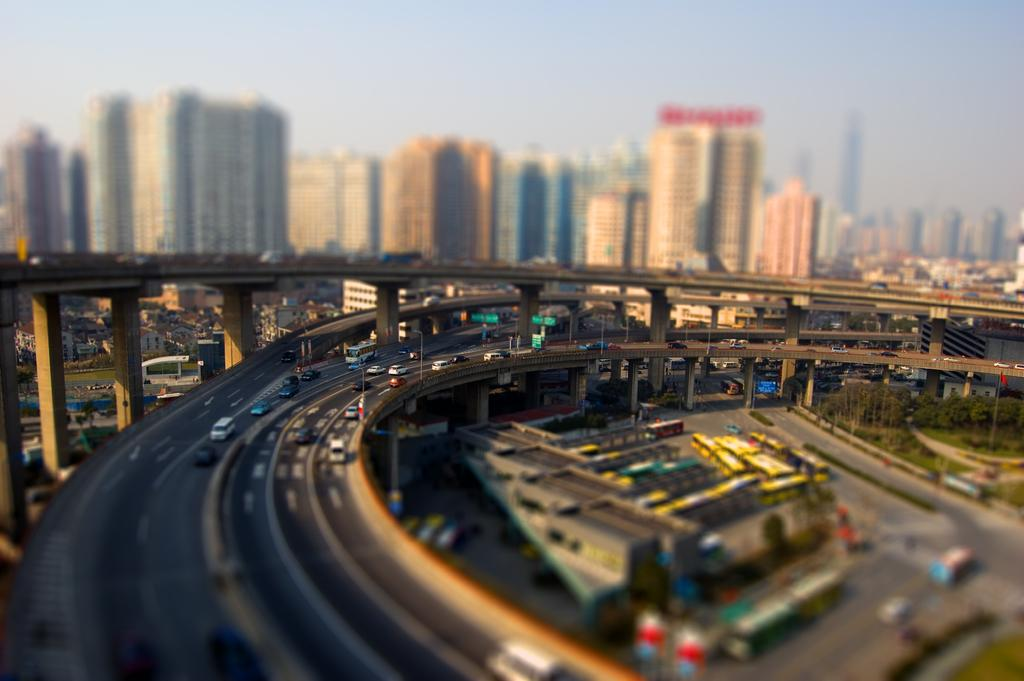How many bridges can be seen in the image? There are three bridges in the image. What is located behind the bridges? Vehicles are visible behind the bridges. What type of structures are present under the bridges? There are buildings under the bridges. What mode of transportation can be seen parked in the image? There are buses parked in the image. What type of bulb is used to light up the chain on the reward in the image? There is no bulb, chain, or reward present in the image. 